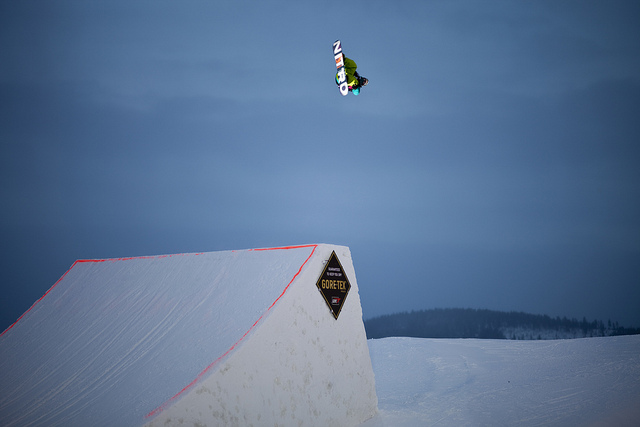<image>How high is the skater? It is unknown how high the skater is. How high is the skater? I don't know how high the skater is. It can be seen as 50 feet, 20 feet, 40 feet, 30 feet, or 12 feet. 